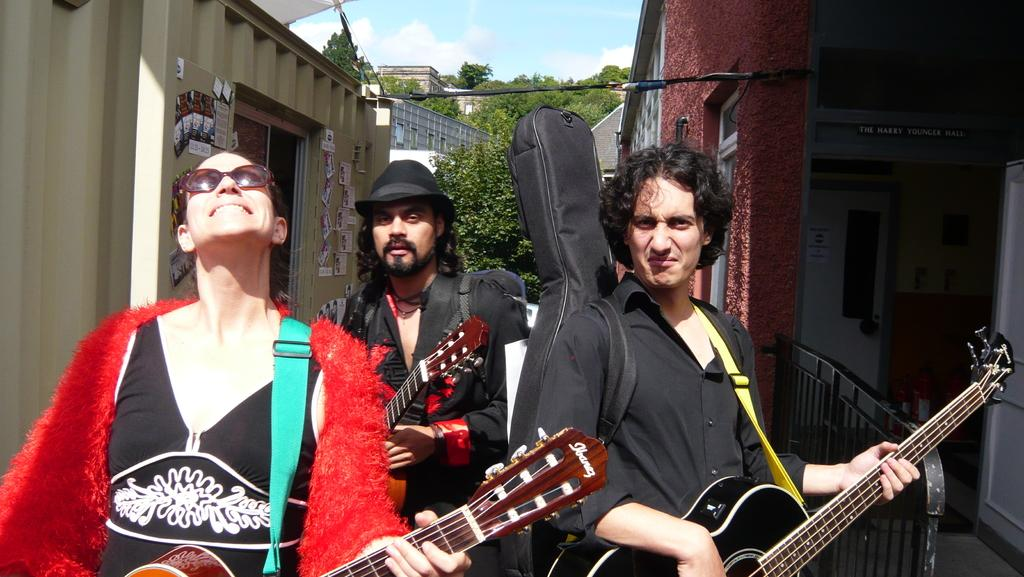What can be seen at the top of the image? The sky with clouds is visible at the top of the image. What is visible in the background of the image? There are buildings and trees in the background of the image. What are the three persons in the image doing? The three persons are standing and playing guitar. Can you describe any architectural features in the image? Yes, there is a door visible in the image. Can you tell me how many bees are buzzing around the guitar in the image? There are no bees present in the image; the focus is on the three persons playing guitar. What type of string is used to play the guitar in the image? The type of string used to play the guitar is not visible in the image, but it is likely to be a standard guitar string. 